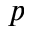<formula> <loc_0><loc_0><loc_500><loc_500>p</formula> 